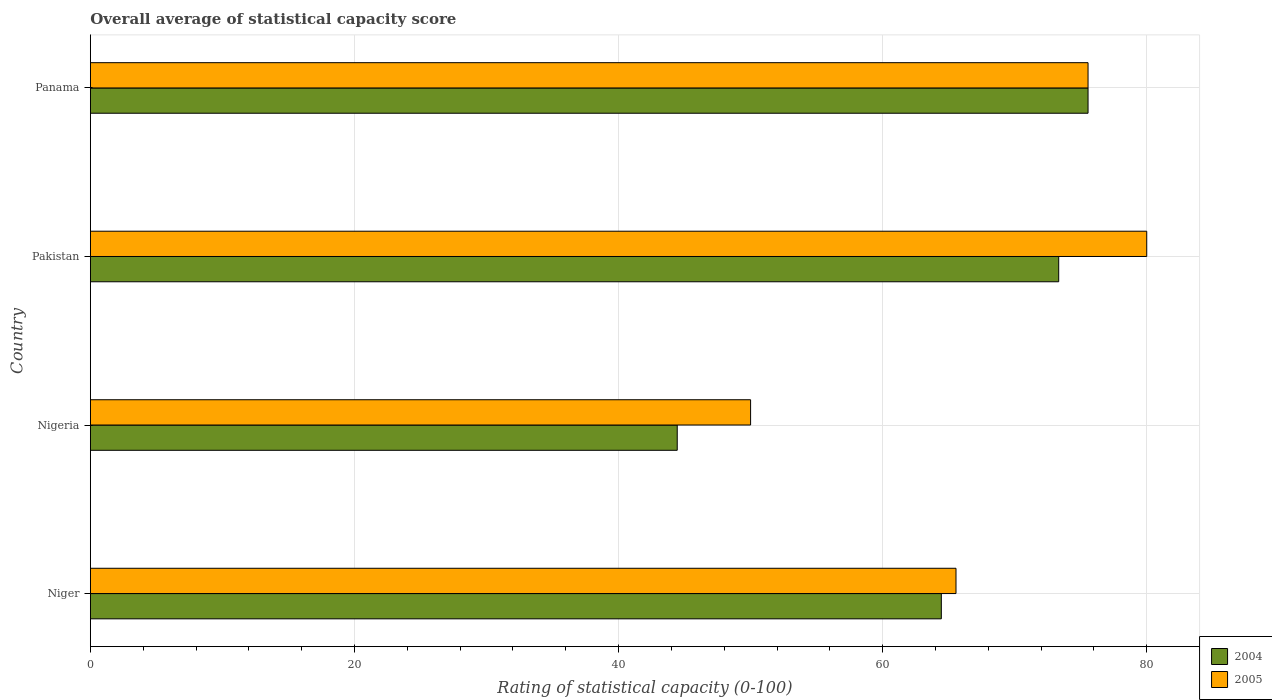How many different coloured bars are there?
Your answer should be compact. 2. Are the number of bars per tick equal to the number of legend labels?
Your answer should be very brief. Yes. How many bars are there on the 1st tick from the top?
Provide a short and direct response. 2. What is the label of the 1st group of bars from the top?
Make the answer very short. Panama. In how many cases, is the number of bars for a given country not equal to the number of legend labels?
Your answer should be compact. 0. What is the rating of statistical capacity in 2005 in Panama?
Provide a succinct answer. 75.56. Across all countries, what is the maximum rating of statistical capacity in 2004?
Provide a short and direct response. 75.56. Across all countries, what is the minimum rating of statistical capacity in 2005?
Your response must be concise. 50. In which country was the rating of statistical capacity in 2005 maximum?
Offer a very short reply. Pakistan. In which country was the rating of statistical capacity in 2005 minimum?
Your answer should be compact. Nigeria. What is the total rating of statistical capacity in 2004 in the graph?
Provide a succinct answer. 257.78. What is the difference between the rating of statistical capacity in 2004 in Niger and that in Panama?
Keep it short and to the point. -11.11. What is the difference between the rating of statistical capacity in 2004 in Panama and the rating of statistical capacity in 2005 in Pakistan?
Your answer should be compact. -4.44. What is the average rating of statistical capacity in 2004 per country?
Provide a succinct answer. 64.44. What is the difference between the rating of statistical capacity in 2005 and rating of statistical capacity in 2004 in Pakistan?
Your answer should be compact. 6.67. In how many countries, is the rating of statistical capacity in 2005 greater than 76 ?
Make the answer very short. 1. What is the ratio of the rating of statistical capacity in 2004 in Pakistan to that in Panama?
Provide a short and direct response. 0.97. What is the difference between the highest and the second highest rating of statistical capacity in 2004?
Your answer should be compact. 2.22. What is the difference between the highest and the lowest rating of statistical capacity in 2004?
Provide a succinct answer. 31.11. How many bars are there?
Ensure brevity in your answer.  8. Are all the bars in the graph horizontal?
Your response must be concise. Yes. How many countries are there in the graph?
Your response must be concise. 4. Where does the legend appear in the graph?
Provide a short and direct response. Bottom right. How are the legend labels stacked?
Keep it short and to the point. Vertical. What is the title of the graph?
Ensure brevity in your answer.  Overall average of statistical capacity score. Does "1998" appear as one of the legend labels in the graph?
Provide a succinct answer. No. What is the label or title of the X-axis?
Your answer should be very brief. Rating of statistical capacity (0-100). What is the Rating of statistical capacity (0-100) of 2004 in Niger?
Offer a very short reply. 64.44. What is the Rating of statistical capacity (0-100) of 2005 in Niger?
Make the answer very short. 65.56. What is the Rating of statistical capacity (0-100) in 2004 in Nigeria?
Your answer should be compact. 44.44. What is the Rating of statistical capacity (0-100) in 2005 in Nigeria?
Your response must be concise. 50. What is the Rating of statistical capacity (0-100) of 2004 in Pakistan?
Provide a succinct answer. 73.33. What is the Rating of statistical capacity (0-100) of 2004 in Panama?
Provide a short and direct response. 75.56. What is the Rating of statistical capacity (0-100) of 2005 in Panama?
Provide a short and direct response. 75.56. Across all countries, what is the maximum Rating of statistical capacity (0-100) of 2004?
Offer a terse response. 75.56. Across all countries, what is the minimum Rating of statistical capacity (0-100) in 2004?
Provide a short and direct response. 44.44. Across all countries, what is the minimum Rating of statistical capacity (0-100) in 2005?
Make the answer very short. 50. What is the total Rating of statistical capacity (0-100) in 2004 in the graph?
Your answer should be compact. 257.78. What is the total Rating of statistical capacity (0-100) in 2005 in the graph?
Your answer should be very brief. 271.11. What is the difference between the Rating of statistical capacity (0-100) of 2005 in Niger and that in Nigeria?
Ensure brevity in your answer.  15.56. What is the difference between the Rating of statistical capacity (0-100) in 2004 in Niger and that in Pakistan?
Give a very brief answer. -8.89. What is the difference between the Rating of statistical capacity (0-100) of 2005 in Niger and that in Pakistan?
Give a very brief answer. -14.44. What is the difference between the Rating of statistical capacity (0-100) of 2004 in Niger and that in Panama?
Provide a succinct answer. -11.11. What is the difference between the Rating of statistical capacity (0-100) in 2005 in Niger and that in Panama?
Provide a short and direct response. -10. What is the difference between the Rating of statistical capacity (0-100) of 2004 in Nigeria and that in Pakistan?
Give a very brief answer. -28.89. What is the difference between the Rating of statistical capacity (0-100) of 2005 in Nigeria and that in Pakistan?
Your response must be concise. -30. What is the difference between the Rating of statistical capacity (0-100) of 2004 in Nigeria and that in Panama?
Provide a succinct answer. -31.11. What is the difference between the Rating of statistical capacity (0-100) in 2005 in Nigeria and that in Panama?
Your answer should be very brief. -25.56. What is the difference between the Rating of statistical capacity (0-100) of 2004 in Pakistan and that in Panama?
Provide a succinct answer. -2.22. What is the difference between the Rating of statistical capacity (0-100) in 2005 in Pakistan and that in Panama?
Offer a terse response. 4.44. What is the difference between the Rating of statistical capacity (0-100) of 2004 in Niger and the Rating of statistical capacity (0-100) of 2005 in Nigeria?
Offer a terse response. 14.44. What is the difference between the Rating of statistical capacity (0-100) of 2004 in Niger and the Rating of statistical capacity (0-100) of 2005 in Pakistan?
Provide a short and direct response. -15.56. What is the difference between the Rating of statistical capacity (0-100) in 2004 in Niger and the Rating of statistical capacity (0-100) in 2005 in Panama?
Make the answer very short. -11.11. What is the difference between the Rating of statistical capacity (0-100) in 2004 in Nigeria and the Rating of statistical capacity (0-100) in 2005 in Pakistan?
Your answer should be very brief. -35.56. What is the difference between the Rating of statistical capacity (0-100) of 2004 in Nigeria and the Rating of statistical capacity (0-100) of 2005 in Panama?
Your answer should be very brief. -31.11. What is the difference between the Rating of statistical capacity (0-100) of 2004 in Pakistan and the Rating of statistical capacity (0-100) of 2005 in Panama?
Offer a terse response. -2.22. What is the average Rating of statistical capacity (0-100) in 2004 per country?
Offer a terse response. 64.44. What is the average Rating of statistical capacity (0-100) of 2005 per country?
Offer a very short reply. 67.78. What is the difference between the Rating of statistical capacity (0-100) of 2004 and Rating of statistical capacity (0-100) of 2005 in Niger?
Your answer should be compact. -1.11. What is the difference between the Rating of statistical capacity (0-100) in 2004 and Rating of statistical capacity (0-100) in 2005 in Nigeria?
Your answer should be compact. -5.56. What is the difference between the Rating of statistical capacity (0-100) of 2004 and Rating of statistical capacity (0-100) of 2005 in Pakistan?
Give a very brief answer. -6.67. What is the ratio of the Rating of statistical capacity (0-100) of 2004 in Niger to that in Nigeria?
Your answer should be compact. 1.45. What is the ratio of the Rating of statistical capacity (0-100) in 2005 in Niger to that in Nigeria?
Offer a terse response. 1.31. What is the ratio of the Rating of statistical capacity (0-100) in 2004 in Niger to that in Pakistan?
Your response must be concise. 0.88. What is the ratio of the Rating of statistical capacity (0-100) in 2005 in Niger to that in Pakistan?
Offer a terse response. 0.82. What is the ratio of the Rating of statistical capacity (0-100) of 2004 in Niger to that in Panama?
Your answer should be compact. 0.85. What is the ratio of the Rating of statistical capacity (0-100) of 2005 in Niger to that in Panama?
Offer a very short reply. 0.87. What is the ratio of the Rating of statistical capacity (0-100) of 2004 in Nigeria to that in Pakistan?
Offer a terse response. 0.61. What is the ratio of the Rating of statistical capacity (0-100) in 2005 in Nigeria to that in Pakistan?
Keep it short and to the point. 0.62. What is the ratio of the Rating of statistical capacity (0-100) in 2004 in Nigeria to that in Panama?
Offer a very short reply. 0.59. What is the ratio of the Rating of statistical capacity (0-100) in 2005 in Nigeria to that in Panama?
Offer a very short reply. 0.66. What is the ratio of the Rating of statistical capacity (0-100) of 2004 in Pakistan to that in Panama?
Give a very brief answer. 0.97. What is the ratio of the Rating of statistical capacity (0-100) in 2005 in Pakistan to that in Panama?
Ensure brevity in your answer.  1.06. What is the difference between the highest and the second highest Rating of statistical capacity (0-100) in 2004?
Ensure brevity in your answer.  2.22. What is the difference between the highest and the second highest Rating of statistical capacity (0-100) of 2005?
Keep it short and to the point. 4.44. What is the difference between the highest and the lowest Rating of statistical capacity (0-100) in 2004?
Offer a very short reply. 31.11. What is the difference between the highest and the lowest Rating of statistical capacity (0-100) of 2005?
Keep it short and to the point. 30. 